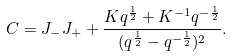Convert formula to latex. <formula><loc_0><loc_0><loc_500><loc_500>C = J _ { - } J _ { + } + \frac { K q ^ { \frac { 1 } { 2 } } + K ^ { - 1 } q ^ { - \frac { 1 } { 2 } } } { ( q ^ { \frac { 1 } { 2 } } - q ^ { - \frac { 1 } { 2 } } ) ^ { 2 } } .</formula> 